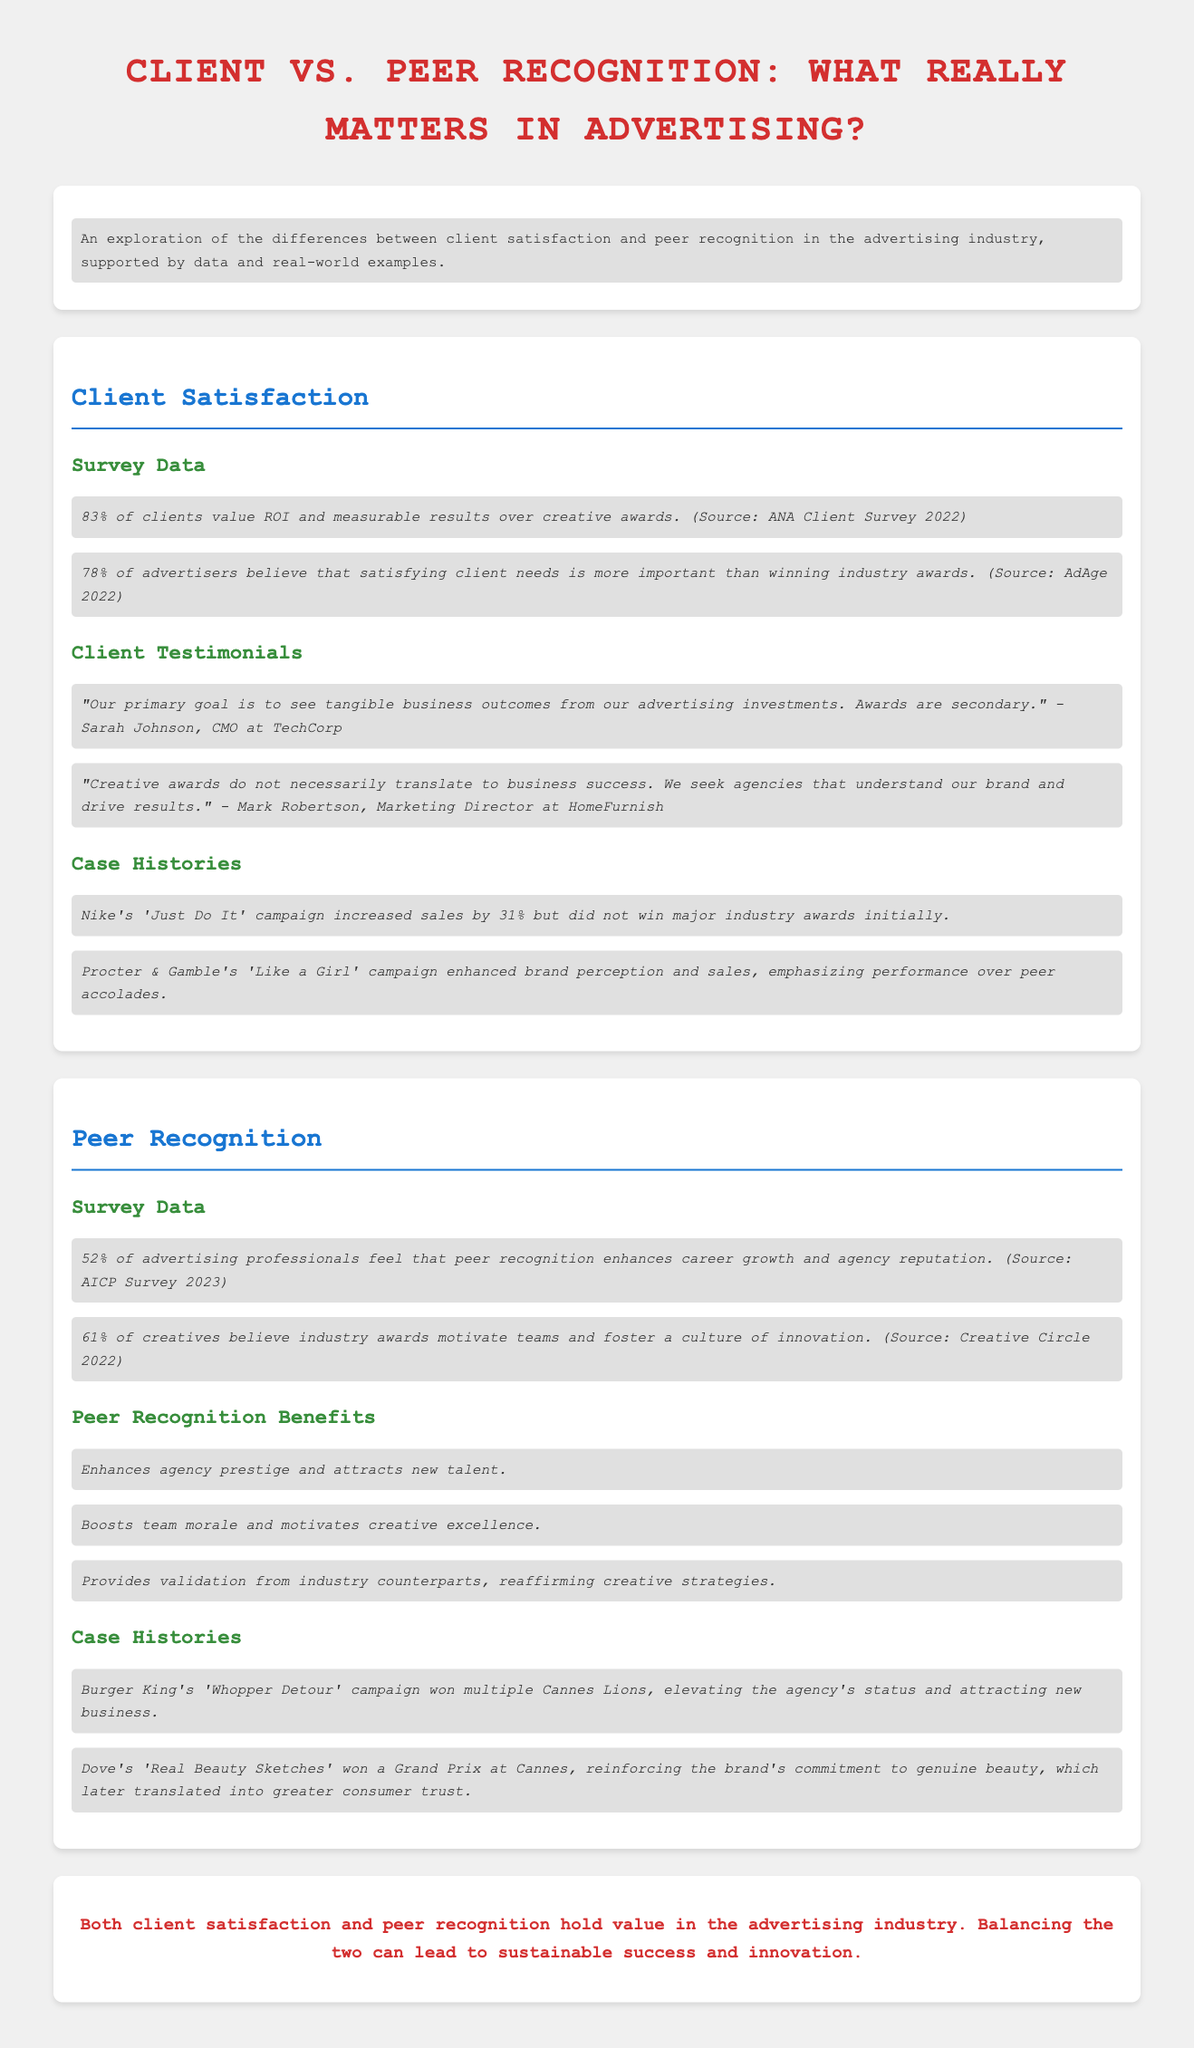What percentage of clients value ROI and measurable results over creative awards? According to the document, 83% of clients value ROI and measurable results over creative awards.
Answer: 83% What do 78% of advertisers prioritize over winning industry awards? The document states that 78% of advertisers believe that satisfying client needs is more important than winning industry awards.
Answer: Satisfying client needs What campaign increased sales by 31% for Nike? The document mentions that Nike's 'Just Do It' campaign increased sales by 31% but did not win major industry awards initially.
Answer: Just Do It What percentage of advertising professionals feel that peer recognition enhances career growth? According to the document, 52% of advertising professionals feel that peer recognition enhances career growth and agency reputation.
Answer: 52% What are the three benefits of peer recognition mentioned in the infographic? The document lists enhancing agency prestige, boosting team morale, and providing validation from industry counterparts as benefits of peer recognition.
Answer: Enhances agency prestige, boosts team morale, provides validation What campaign won multiple Cannes Lions and elevated Burger King's agency status? The document states that Burger King's 'Whopper Detour' campaign won multiple Cannes Lions.
Answer: Whopper Detour What do 61% of creatives believe industry awards do? The document indicates that 61% of creatives believe industry awards motivate teams and foster a culture of innovation.
Answer: Motivate teams and foster innovation What can balancing client satisfaction and peer recognition lead to? The conclusion in the document suggests that balancing the two can lead to sustainable success and innovation.
Answer: Sustainable success and innovation 